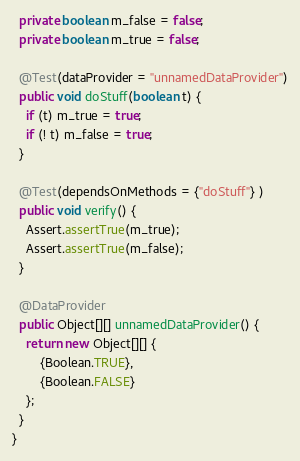<code> <loc_0><loc_0><loc_500><loc_500><_Java_>  private boolean m_false = false;
  private boolean m_true = false;
  
  @Test(dataProvider = "unnamedDataProvider")
  public void doStuff(boolean t) {
    if (t) m_true = true;
    if (! t) m_false = true;
  }
  
  @Test(dependsOnMethods = {"doStuff"} )
  public void verify() {
    Assert.assertTrue(m_true);
    Assert.assertTrue(m_false);    
  }
  
  @DataProvider
  public Object[][] unnamedDataProvider() {
    return new Object[][] {
        {Boolean.TRUE},
        {Boolean.FALSE}
    };
  }
}
</code> 